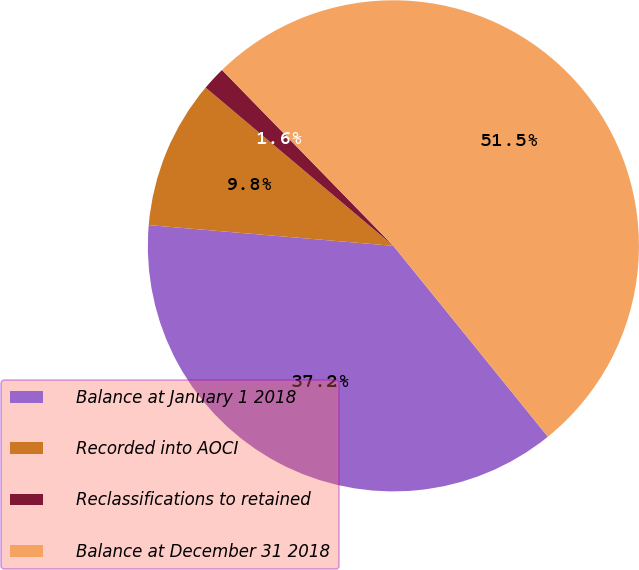Convert chart. <chart><loc_0><loc_0><loc_500><loc_500><pie_chart><fcel>Balance at January 1 2018<fcel>Recorded into AOCI<fcel>Reclassifications to retained<fcel>Balance at December 31 2018<nl><fcel>37.18%<fcel>9.8%<fcel>1.56%<fcel>51.47%<nl></chart> 